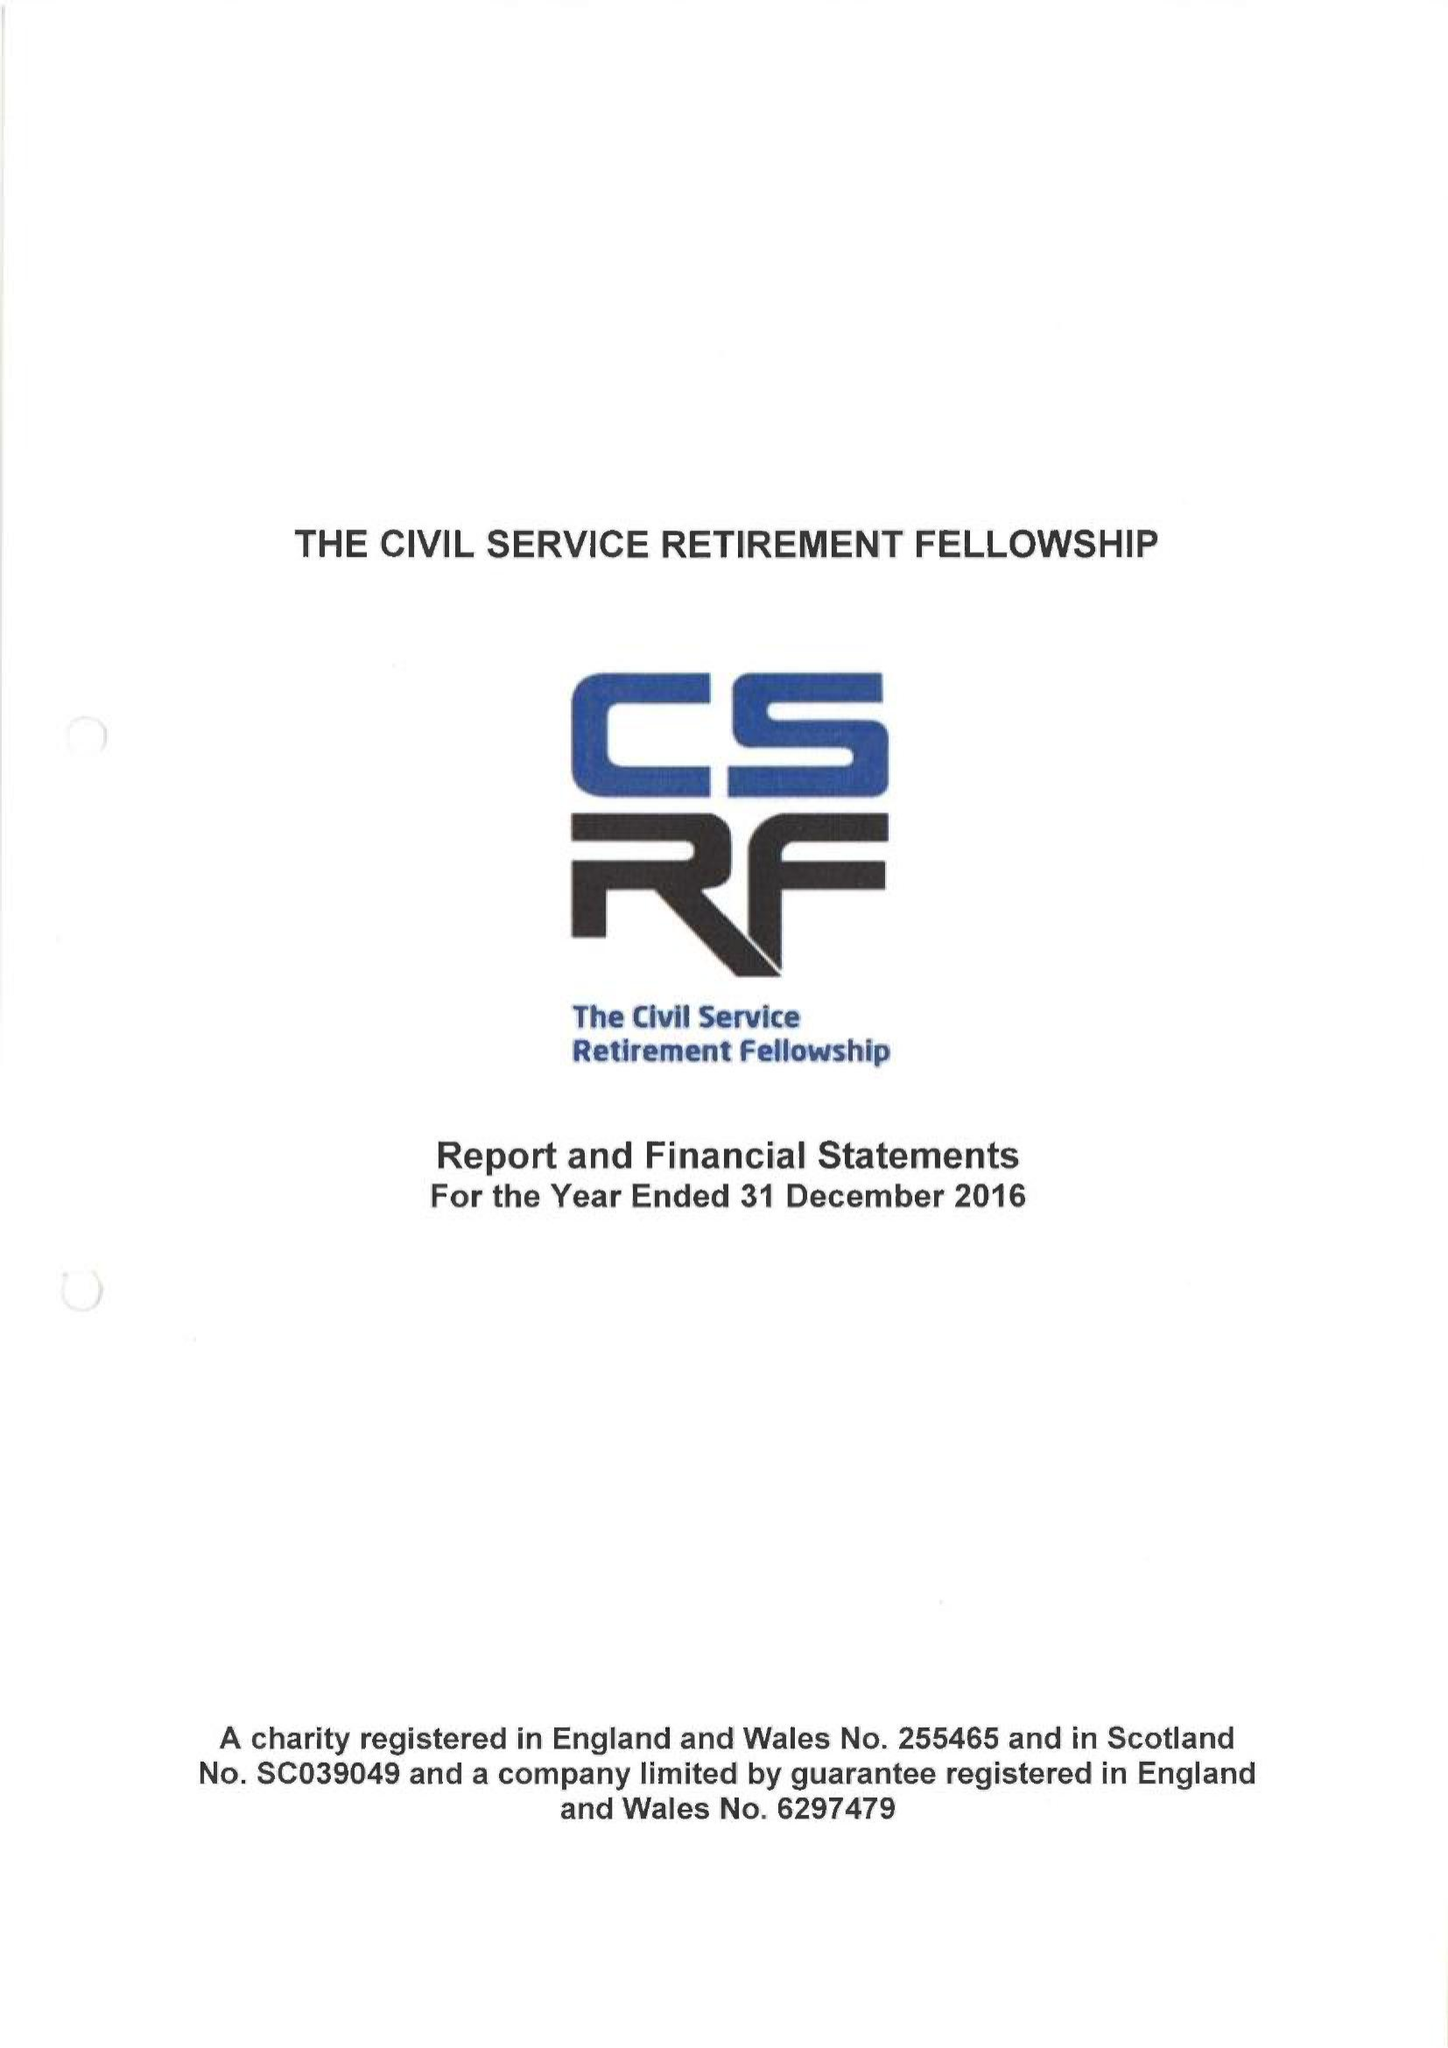What is the value for the address__street_line?
Answer the question using a single word or phrase. CLARENCE ROAD 